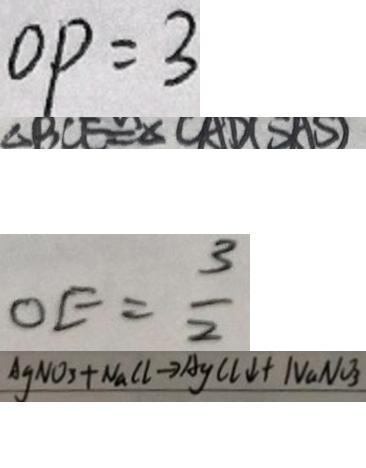Convert formula to latex. <formula><loc_0><loc_0><loc_500><loc_500>O P = 3 
 \Delta B C E \cong \Delta C A D ( S A S ) 
 O E = \frac { 3 } { 2 } 
 A g N O _ { 3 } + N a C l \rightarrow A g C l \downarrow + N a N O _ { 3 }</formula> 